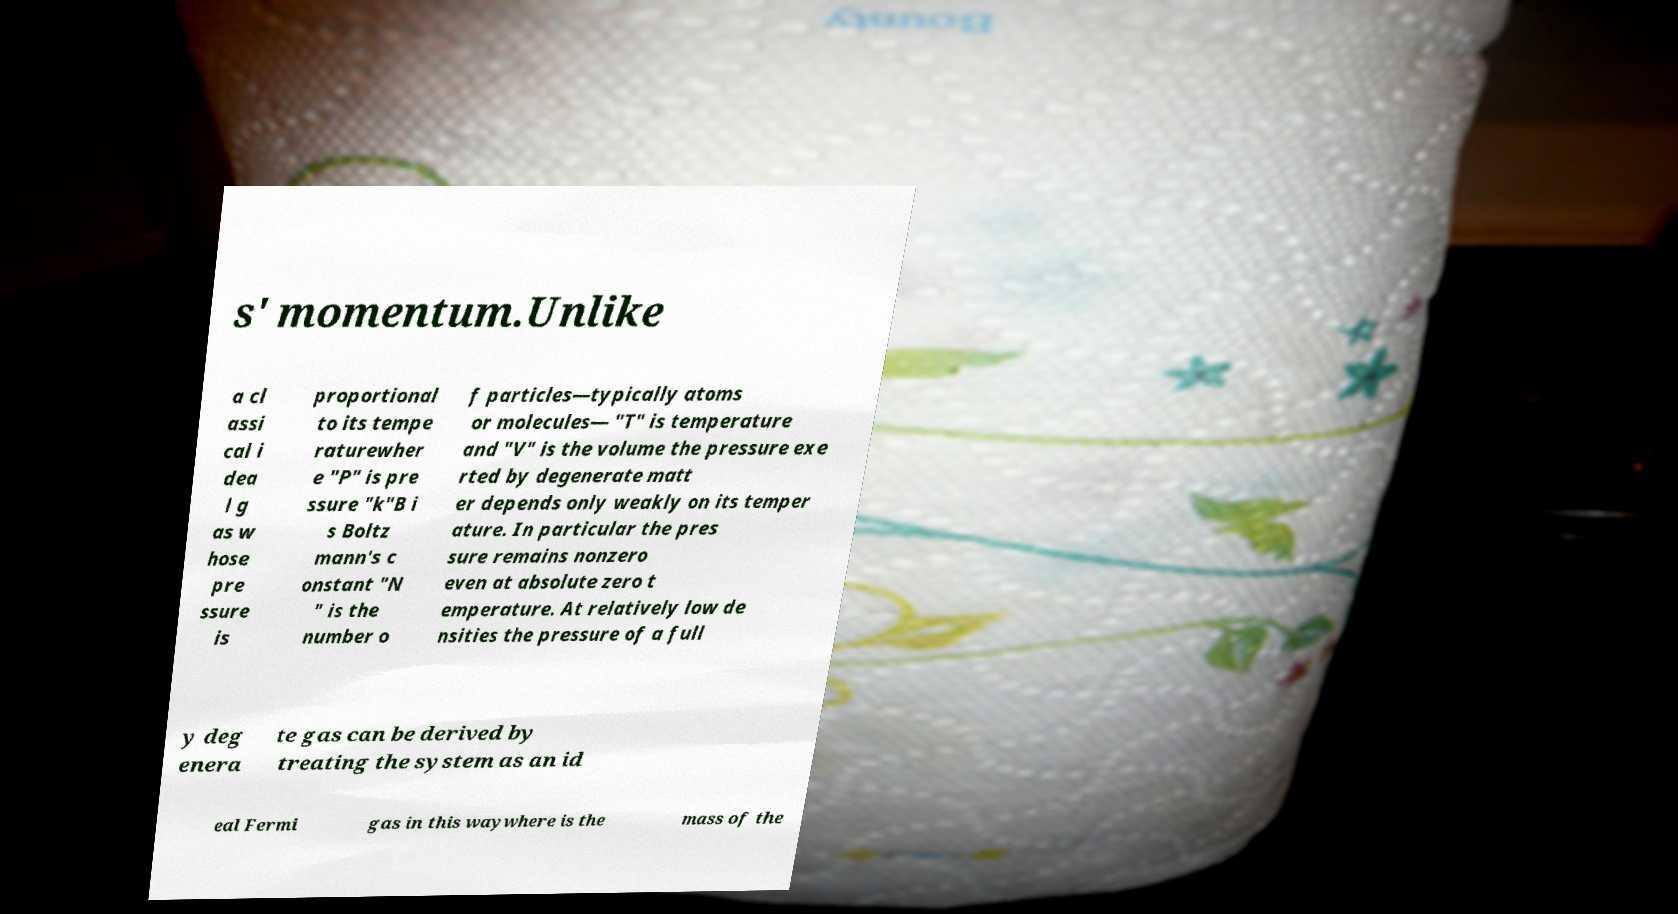Can you accurately transcribe the text from the provided image for me? s' momentum.Unlike a cl assi cal i dea l g as w hose pre ssure is proportional to its tempe raturewher e "P" is pre ssure "k"B i s Boltz mann's c onstant "N " is the number o f particles—typically atoms or molecules— "T" is temperature and "V" is the volume the pressure exe rted by degenerate matt er depends only weakly on its temper ature. In particular the pres sure remains nonzero even at absolute zero t emperature. At relatively low de nsities the pressure of a full y deg enera te gas can be derived by treating the system as an id eal Fermi gas in this waywhere is the mass of the 